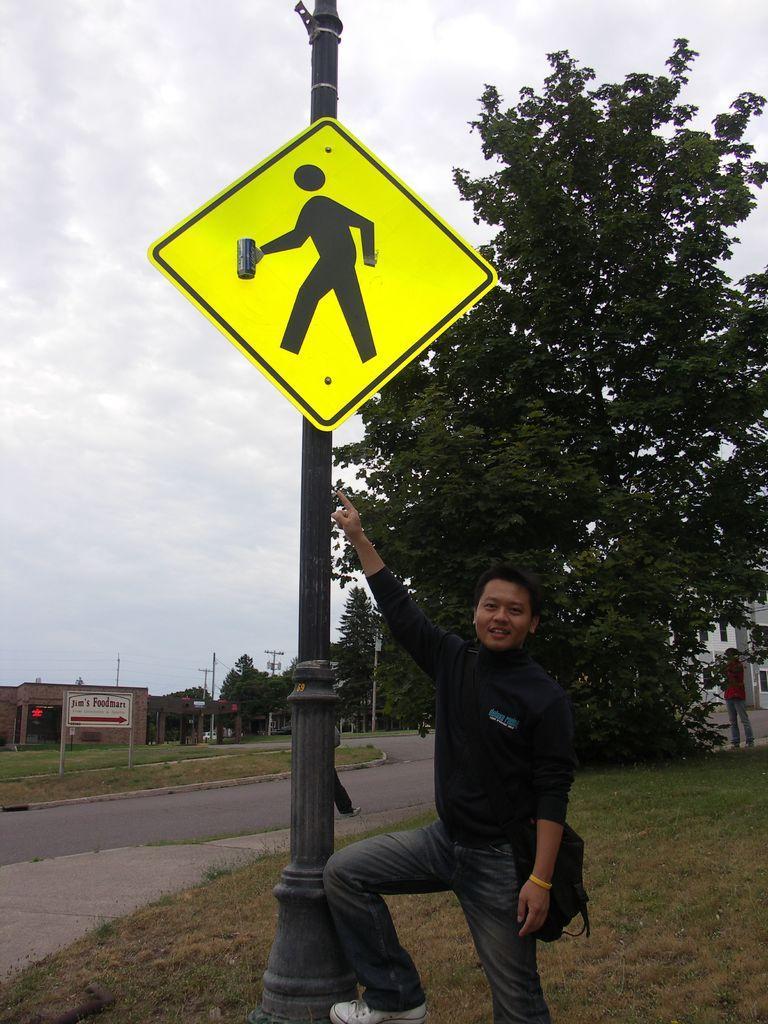Can you describe this image briefly? In this image there is a man standing. He is wearing a bag. Beside him there is a pole. There is a sign board to the pole. There is grass on the ground. Behind the pole there is a tree. There is a person standing near the tree. Beside the tree there is a road. In the background there are buildings, poles and trees. On the other side of the road there is a board. At the top there is the sky. 